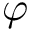<formula> <loc_0><loc_0><loc_500><loc_500>\varphi</formula> 